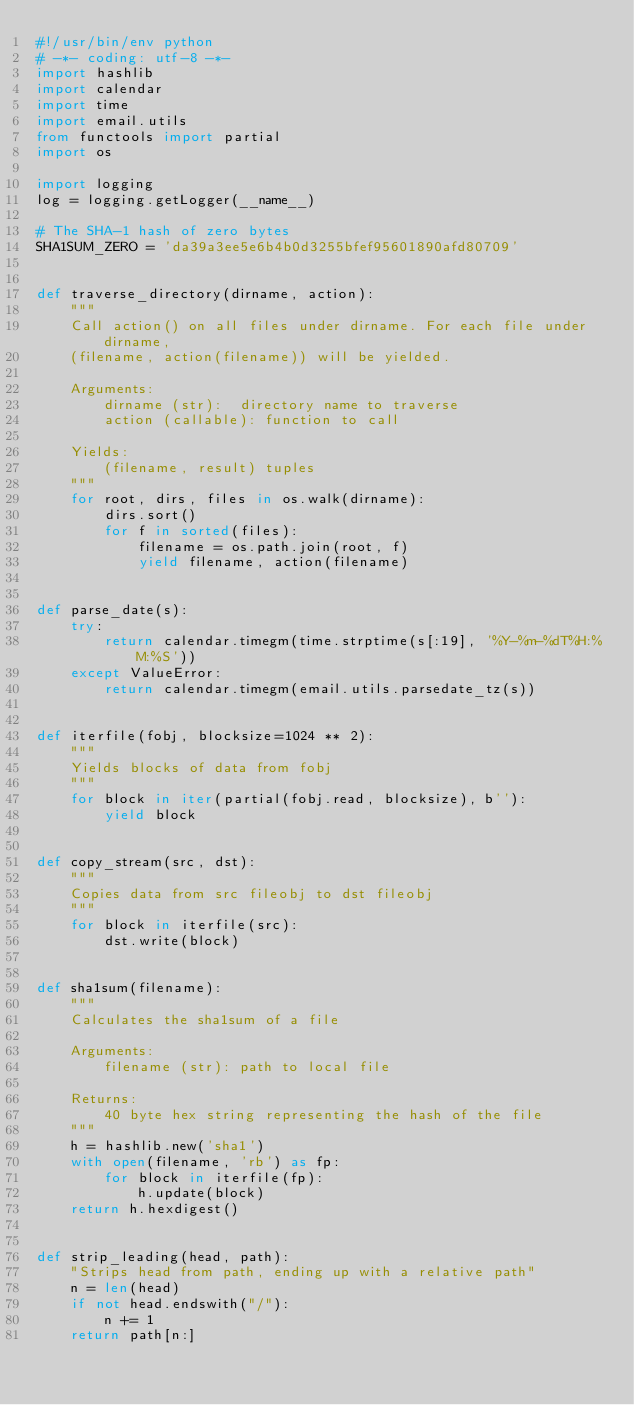<code> <loc_0><loc_0><loc_500><loc_500><_Python_>#!/usr/bin/env python
# -*- coding: utf-8 -*-
import hashlib
import calendar
import time
import email.utils
from functools import partial
import os

import logging
log = logging.getLogger(__name__)

# The SHA-1 hash of zero bytes
SHA1SUM_ZERO = 'da39a3ee5e6b4b0d3255bfef95601890afd80709'


def traverse_directory(dirname, action):
    """
    Call action() on all files under dirname. For each file under dirname,
    (filename, action(filename)) will be yielded.

    Arguments:
        dirname (str):  directory name to traverse
        action (callable): function to call

    Yields:
        (filename, result) tuples
    """
    for root, dirs, files in os.walk(dirname):
        dirs.sort()
        for f in sorted(files):
            filename = os.path.join(root, f)
            yield filename, action(filename)


def parse_date(s):
    try:
        return calendar.timegm(time.strptime(s[:19], '%Y-%m-%dT%H:%M:%S'))
    except ValueError:
        return calendar.timegm(email.utils.parsedate_tz(s))


def iterfile(fobj, blocksize=1024 ** 2):
    """
    Yields blocks of data from fobj
    """
    for block in iter(partial(fobj.read, blocksize), b''):
        yield block


def copy_stream(src, dst):
    """
    Copies data from src fileobj to dst fileobj
    """
    for block in iterfile(src):
        dst.write(block)


def sha1sum(filename):
    """
    Calculates the sha1sum of a file

    Arguments:
        filename (str): path to local file

    Returns:
        40 byte hex string representing the hash of the file
    """
    h = hashlib.new('sha1')
    with open(filename, 'rb') as fp:
        for block in iterfile(fp):
            h.update(block)
    return h.hexdigest()


def strip_leading(head, path):
    "Strips head from path, ending up with a relative path"
    n = len(head)
    if not head.endswith("/"):
        n += 1
    return path[n:]
</code> 